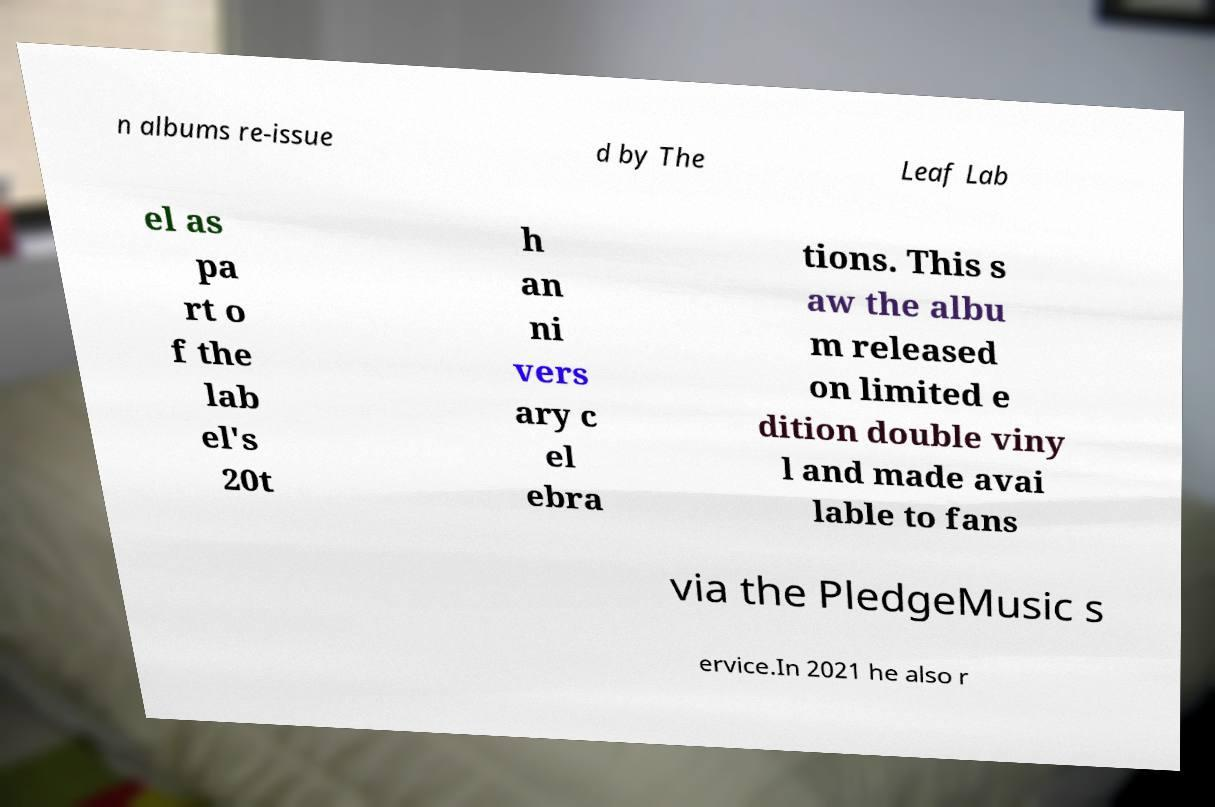There's text embedded in this image that I need extracted. Can you transcribe it verbatim? n albums re-issue d by The Leaf Lab el as pa rt o f the lab el's 20t h an ni vers ary c el ebra tions. This s aw the albu m released on limited e dition double viny l and made avai lable to fans via the PledgeMusic s ervice.In 2021 he also r 